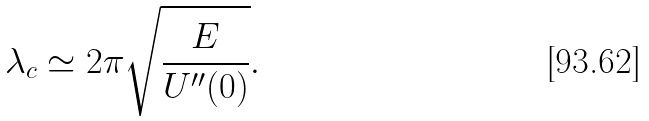<formula> <loc_0><loc_0><loc_500><loc_500>\lambda _ { c } \simeq 2 \pi \sqrt { \frac { E } { U ^ { \prime \prime } ( 0 ) } } .</formula> 